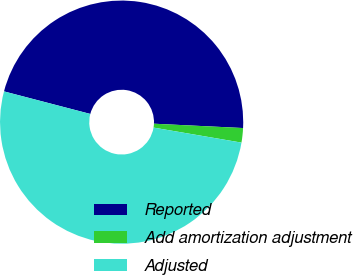Convert chart to OTSL. <chart><loc_0><loc_0><loc_500><loc_500><pie_chart><fcel>Reported<fcel>Add amortization adjustment<fcel>Adjusted<nl><fcel>46.7%<fcel>1.92%<fcel>51.37%<nl></chart> 